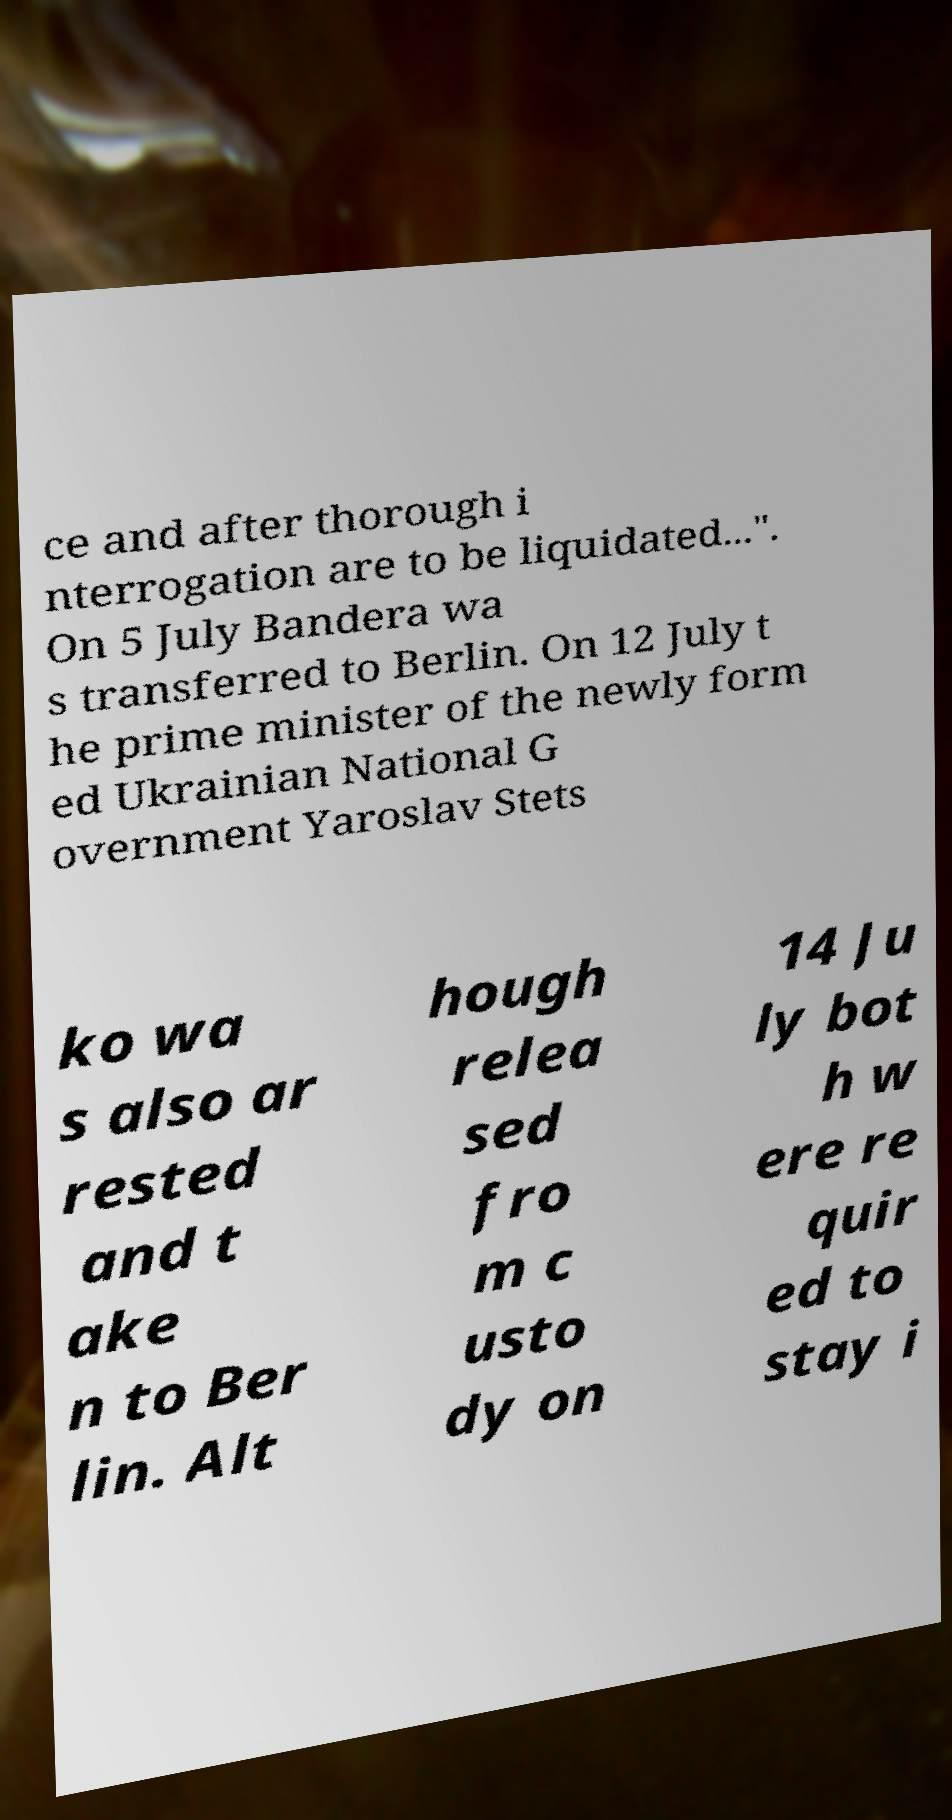Please read and relay the text visible in this image. What does it say? ce and after thorough i nterrogation are to be liquidated...". On 5 July Bandera wa s transferred to Berlin. On 12 July t he prime minister of the newly form ed Ukrainian National G overnment Yaroslav Stets ko wa s also ar rested and t ake n to Ber lin. Alt hough relea sed fro m c usto dy on 14 Ju ly bot h w ere re quir ed to stay i 